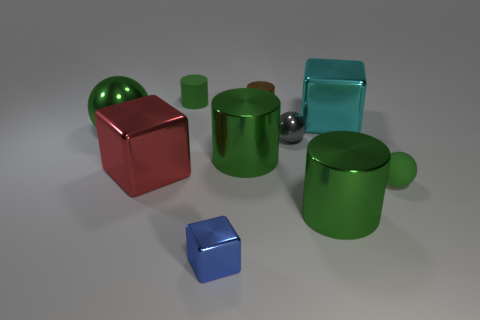How many green cylinders must be subtracted to get 1 green cylinders? 2 Subtract all purple spheres. How many green cylinders are left? 3 Subtract all balls. How many objects are left? 7 Add 4 small blue cubes. How many small blue cubes are left? 5 Add 8 big red shiny objects. How many big red shiny objects exist? 9 Subtract 0 purple spheres. How many objects are left? 10 Subtract all small metal blocks. Subtract all green rubber cylinders. How many objects are left? 8 